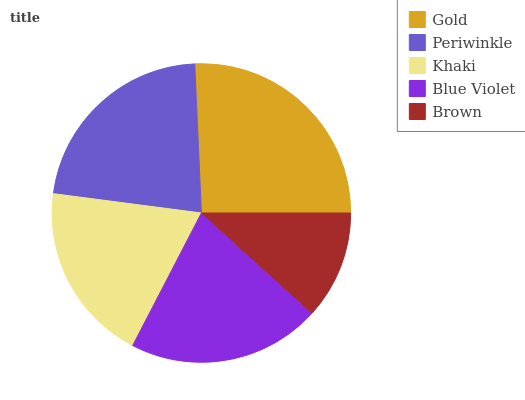Is Brown the minimum?
Answer yes or no. Yes. Is Gold the maximum?
Answer yes or no. Yes. Is Periwinkle the minimum?
Answer yes or no. No. Is Periwinkle the maximum?
Answer yes or no. No. Is Gold greater than Periwinkle?
Answer yes or no. Yes. Is Periwinkle less than Gold?
Answer yes or no. Yes. Is Periwinkle greater than Gold?
Answer yes or no. No. Is Gold less than Periwinkle?
Answer yes or no. No. Is Blue Violet the high median?
Answer yes or no. Yes. Is Blue Violet the low median?
Answer yes or no. Yes. Is Gold the high median?
Answer yes or no. No. Is Periwinkle the low median?
Answer yes or no. No. 